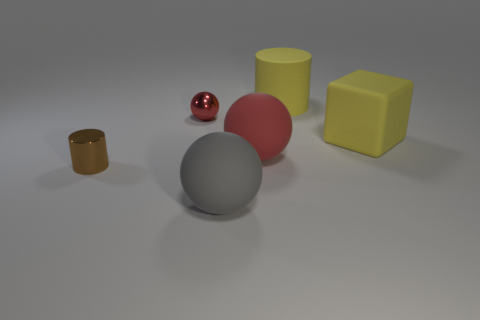Do the matte object behind the matte cube and the small object behind the brown shiny thing have the same shape?
Give a very brief answer. No. Are there the same number of big gray rubber spheres behind the brown metal thing and small red balls?
Your response must be concise. No. There is a large matte thing that is the same shape as the tiny brown thing; what color is it?
Offer a very short reply. Yellow. Is the ball that is in front of the small metallic cylinder made of the same material as the yellow block?
Give a very brief answer. Yes. How many tiny objects are red shiny cylinders or metallic objects?
Your answer should be very brief. 2. What size is the brown cylinder?
Provide a succinct answer. Small. Does the brown metal cylinder have the same size as the red thing that is on the left side of the gray matte thing?
Your response must be concise. Yes. What number of red objects are either large matte cylinders or rubber things?
Provide a succinct answer. 1. What number of large gray rubber things are there?
Ensure brevity in your answer.  1. How big is the cylinder to the left of the big gray matte ball?
Give a very brief answer. Small. 